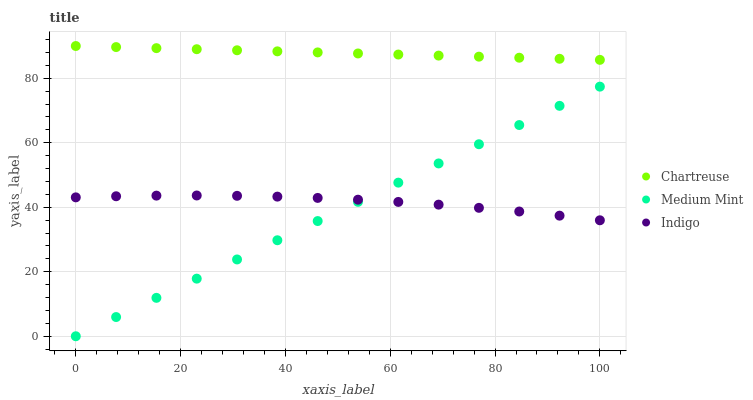Does Medium Mint have the minimum area under the curve?
Answer yes or no. Yes. Does Chartreuse have the maximum area under the curve?
Answer yes or no. Yes. Does Indigo have the minimum area under the curve?
Answer yes or no. No. Does Indigo have the maximum area under the curve?
Answer yes or no. No. Is Medium Mint the smoothest?
Answer yes or no. Yes. Is Indigo the roughest?
Answer yes or no. Yes. Is Chartreuse the smoothest?
Answer yes or no. No. Is Chartreuse the roughest?
Answer yes or no. No. Does Medium Mint have the lowest value?
Answer yes or no. Yes. Does Indigo have the lowest value?
Answer yes or no. No. Does Chartreuse have the highest value?
Answer yes or no. Yes. Does Indigo have the highest value?
Answer yes or no. No. Is Indigo less than Chartreuse?
Answer yes or no. Yes. Is Chartreuse greater than Indigo?
Answer yes or no. Yes. Does Indigo intersect Medium Mint?
Answer yes or no. Yes. Is Indigo less than Medium Mint?
Answer yes or no. No. Is Indigo greater than Medium Mint?
Answer yes or no. No. Does Indigo intersect Chartreuse?
Answer yes or no. No. 